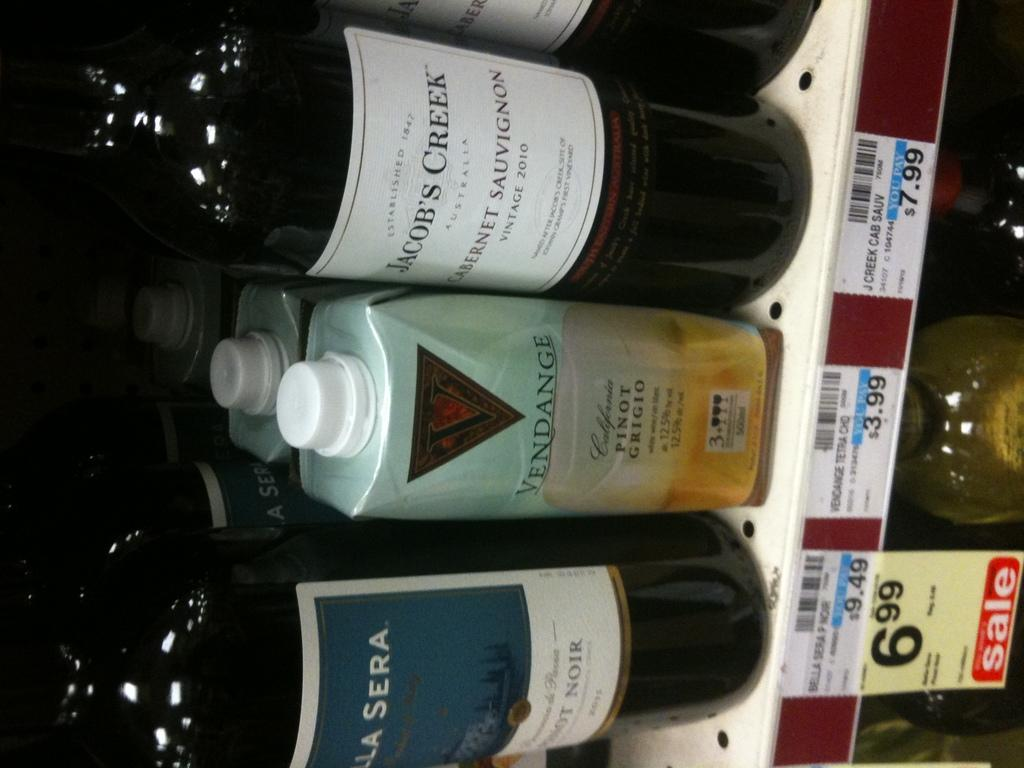Provide a one-sentence caption for the provided image. A bottle of Jacob's Creek wine is on the shelf of a store. 